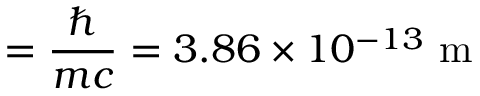<formula> <loc_0><loc_0><loc_500><loc_500>\ = { \frac { } { m c } } = 3 . 8 6 \times 1 0 ^ { - 1 3 } { m }</formula> 